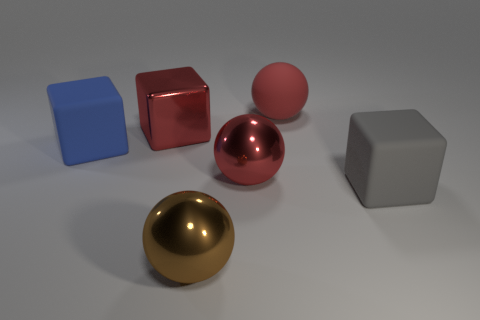Add 4 blue matte objects. How many objects exist? 10 Subtract 0 purple spheres. How many objects are left? 6 Subtract all brown rubber blocks. Subtract all large balls. How many objects are left? 3 Add 4 brown objects. How many brown objects are left? 5 Add 1 brown things. How many brown things exist? 2 